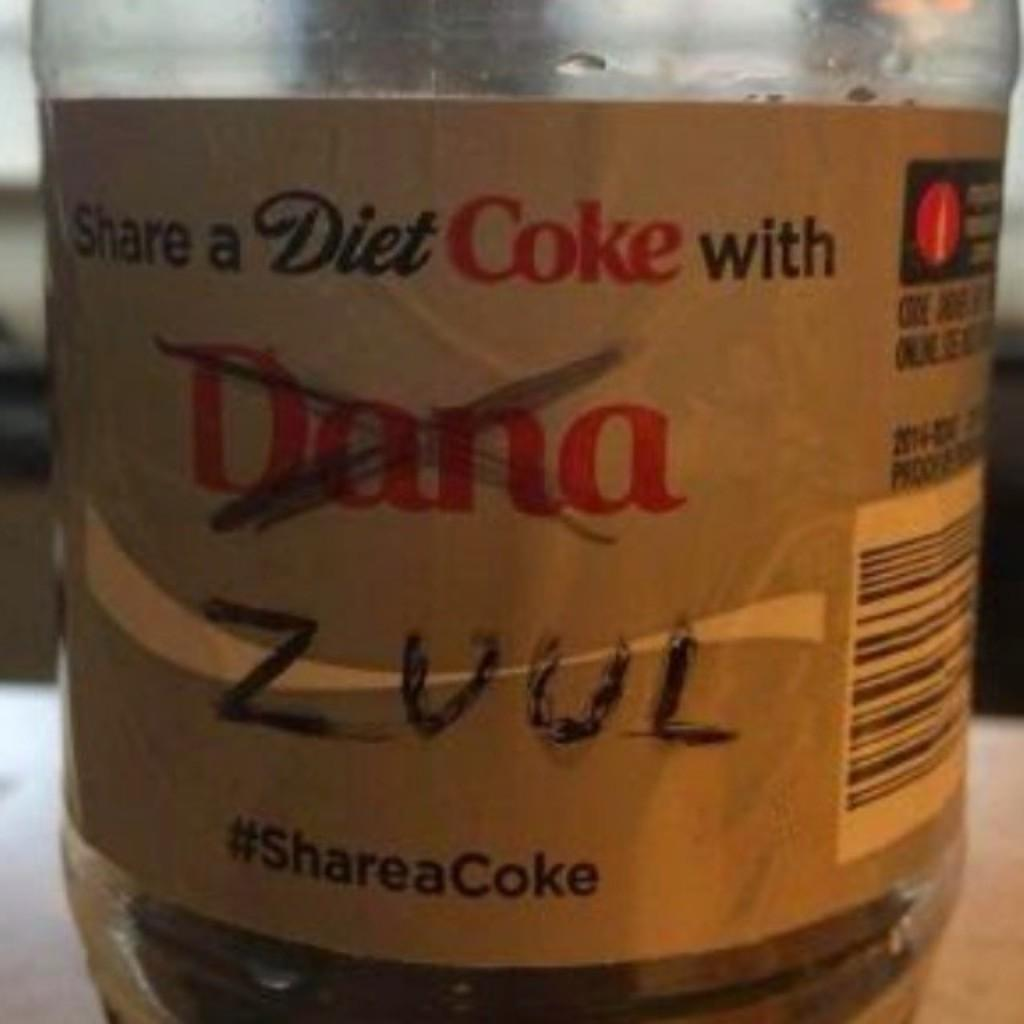Provide a one-sentence caption for the provided image. A Diet Coke label on which one name has been crossed out and another written in. 